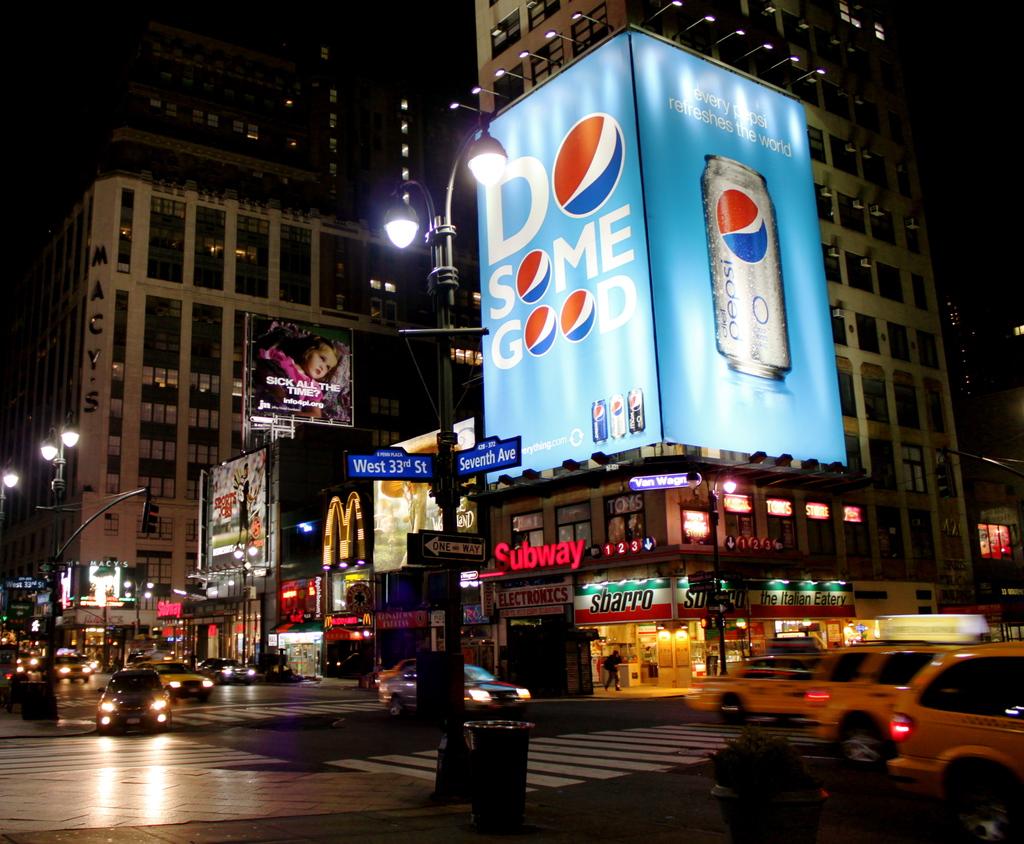What drink is being advertised?
Your response must be concise. Pepsi. 